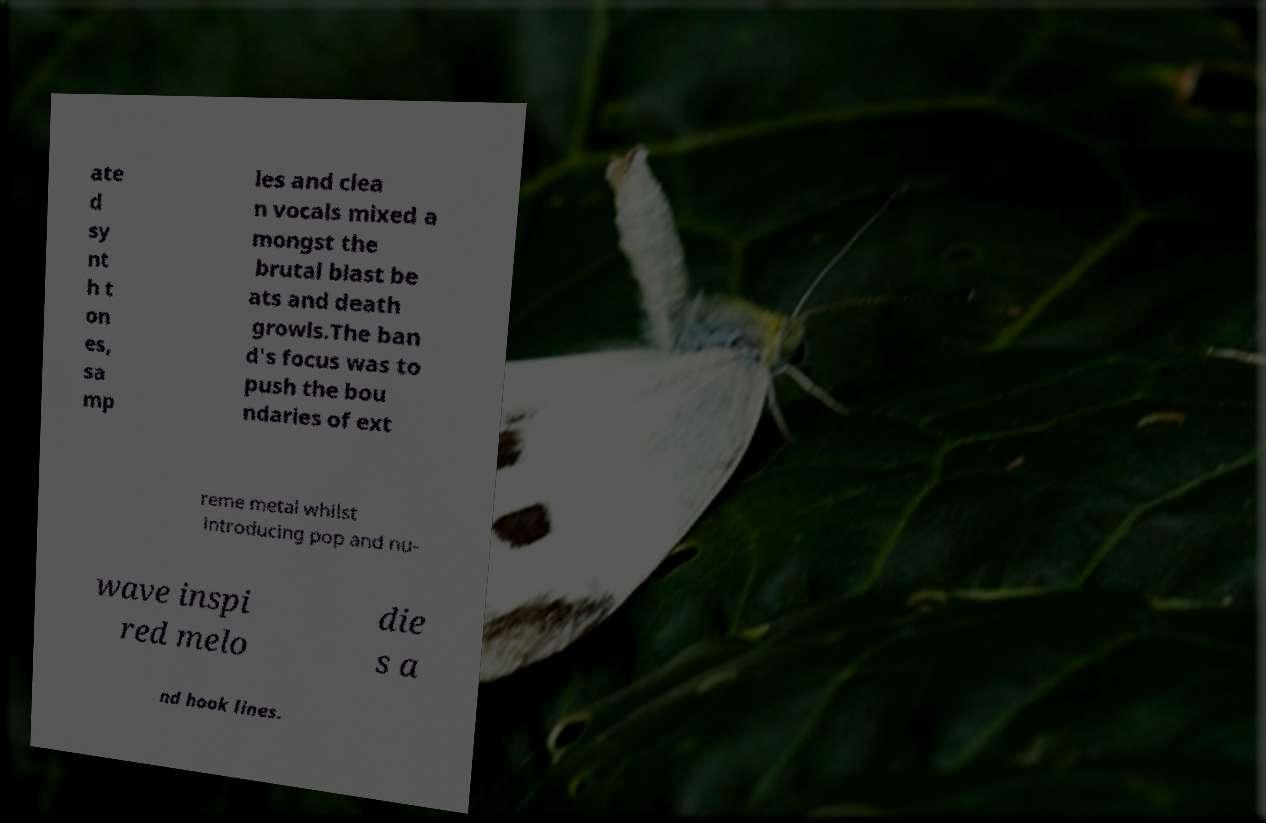Please identify and transcribe the text found in this image. ate d sy nt h t on es, sa mp les and clea n vocals mixed a mongst the brutal blast be ats and death growls.The ban d's focus was to push the bou ndaries of ext reme metal whilst introducing pop and nu- wave inspi red melo die s a nd hook lines. 